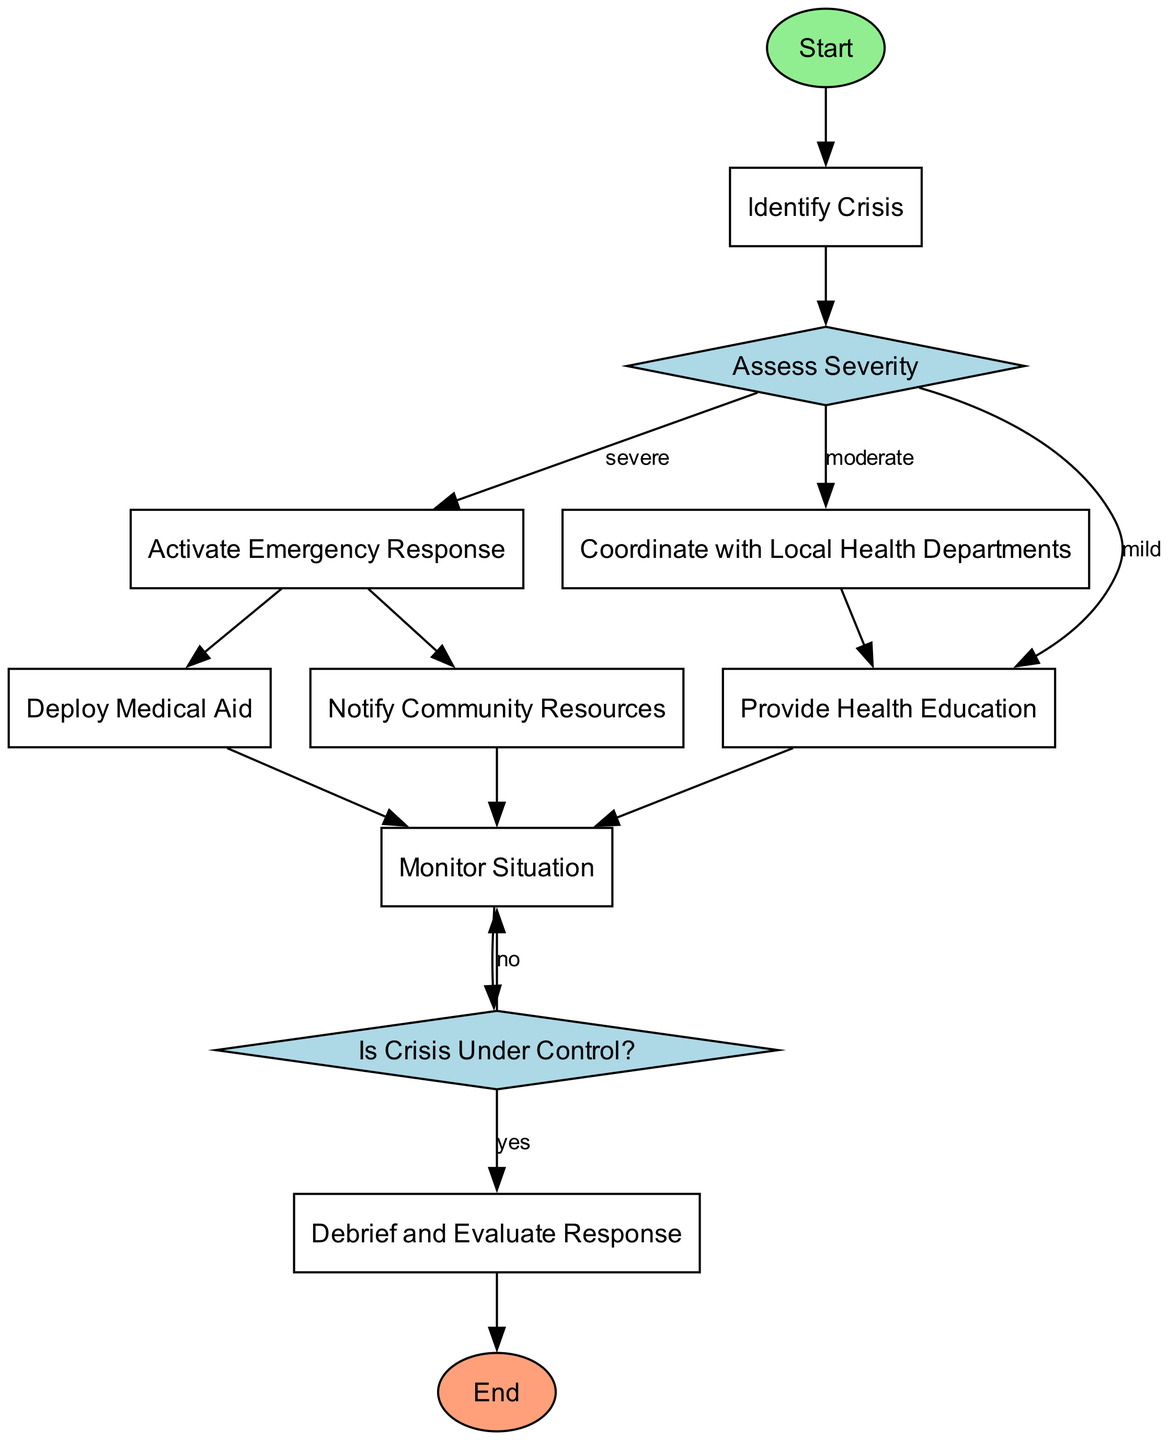What's the first step in the diagram? The first step in the diagram is shown as the "Start" node, which indicates the beginning of the emergency response procedure.
Answer: Start How many decision points are in the diagram? The diagram contains two decision points: "Assess Severity" and "Is Crisis Under Control?" Each of these nodes directs the flow based on certain conditions.
Answer: 2 What happens after a crisis is identified as severe? After the crisis is identified as severe, the next step is to "Activate Emergency Response," which starts the action to address the crisis.
Answer: Activate Emergency Response What does the node "Provide Health Education" connect to? The "Provide Health Education" node connects to "Monitor Situation," indicating that after providing education, the situation should be monitored for ongoing developments.
Answer: Monitor Situation If the crisis is identified as moderate, what is the subsequent action in the flowchart? If the crisis is identified as moderate, the subsequent action in the flowchart is to "Coordinate with Local Health Departments," which involves working with local agencies to manage the situation.
Answer: Coordinate with Local Health Departments What occurs if the crisis is not under control? If the crisis is not under control, the flowchart loops back to "Monitor Situation," indicating that the situation requires ongoing attention and assessment.
Answer: Monitor Situation What is the final step in the procedure after evaluating the response? The final step in the procedure after evaluating the response is "End," which signifies the conclusion of the emergency response process.
Answer: End What actions are taken after activating emergency response? After activating emergency response, two actions are taken: "Deploy Medical Aid" and "Notify Community Resources," indicating a comprehensive approach to handle the crisis.
Answer: Deploy Medical Aid and Notify Community Resources What is the condition for moving to the "Debrief and Evaluate Response"? The condition for moving to "Debrief and Evaluate Response" is that the crisis must be under control, as determined by the previous decision point.
Answer: Yes 